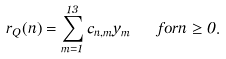Convert formula to latex. <formula><loc_0><loc_0><loc_500><loc_500>r _ { Q } ( n ) = \sum _ { m = 1 } ^ { 1 3 } c _ { n , m } y _ { m } \quad f o r n \geq 0 .</formula> 